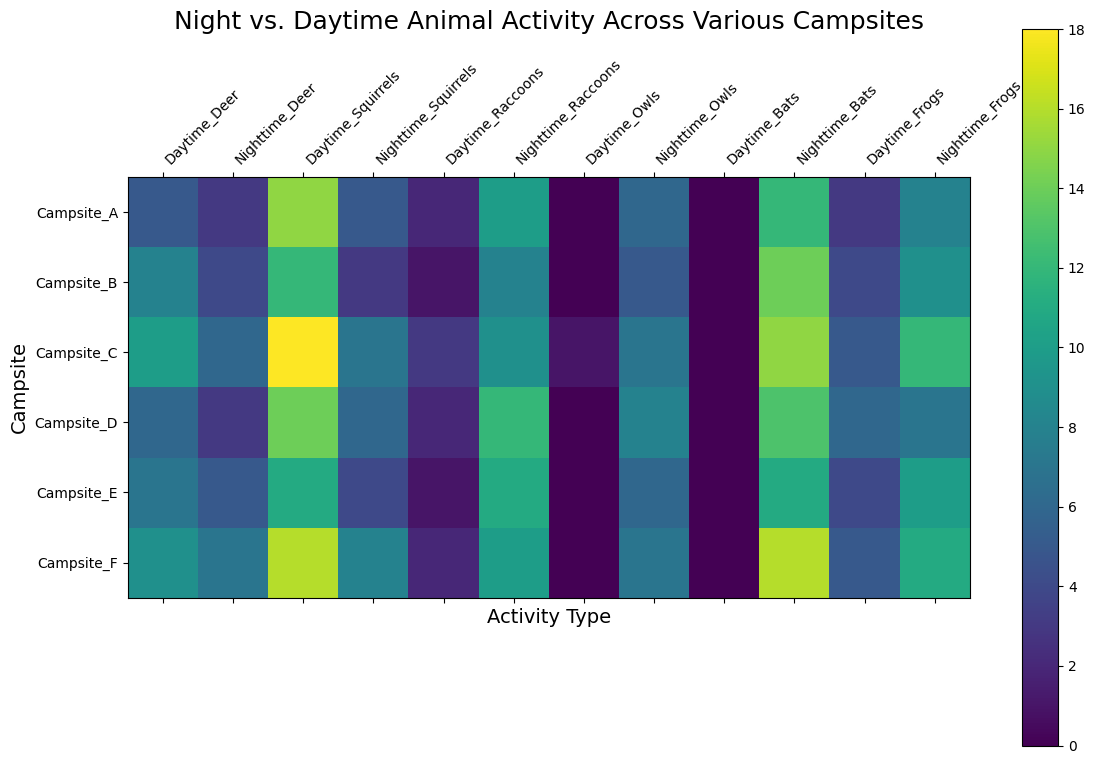What campsite has the highest nocturnal bat activity? Look at the heatmap section that compares nocturnal (Nighttime) bat activity across all campsites. Identify the campsite with the darkest (highest) color shade corresponding to Nighttime_Bats.
Answer: Campsite_F Which animal has the largest difference in activity between day and night at Campsite_B? Check for each animal category at Campsite_B by subtracting the daytime value from the nighttime value. The animal with the largest resulting difference is the answer.
Answer: Bats Which animal is most active during the daytime across all campsites? Identify the animal category with the consistently highest daytime values (lighter shades) across the heatmap sections for every campsite.
Answer: Squirrels Compare the nighttime raccoon activity between Campsite_D and Campsite_E. Which one is higher? Look at the entries for Nighttime_Raccoons under Campsite_D and Campsite_E. Compare the shades or recorded values directly.
Answer: Campsite_D What is the total number of nocturnal owl sightings across all campsites? Sum the recorded owl sightings during the nighttime for all campsites: 6+5+7+8+6+7 = 39.
Answer: 39 Is there any campsite where no nocturnal deer activity is observed? Look for the shade corresponding to Nighttime_Deer and check if any campsite has a value of zero (the lightest shade).
Answer: No Which campsite has the most even distribution of animal activity between day and night? Evaluate each campsite by comparing how close the animal activity values are between day and night. Consider the campsite where the difference in values between day and night is minimal across all animal categories.
Answer: Campsite_A How does Campsite_F rank in terms of nighttime squirrel activity compared to other campsites? Compare the Nighttime_Squirrels values across all campsites. Rank Campsite_F based on the proximity of its value (medium shade) relative to other campsites’ values.
Answer: Higher than most, except Campsite_C Which campsite has the highest overall activity from bats? Sum the recorded values for both daytime and nighttime bat activity at each campsite, and identify the campsite with the highest total.
Answer: Campsite_F 